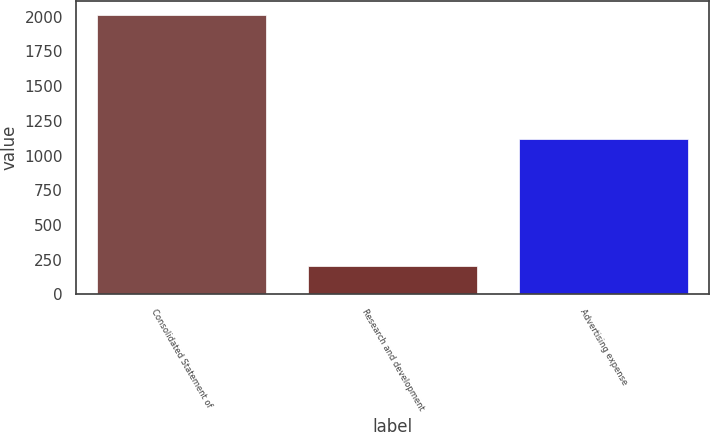<chart> <loc_0><loc_0><loc_500><loc_500><bar_chart><fcel>Consolidated Statement of<fcel>Research and development<fcel>Advertising expense<nl><fcel>2012<fcel>206<fcel>1120<nl></chart> 